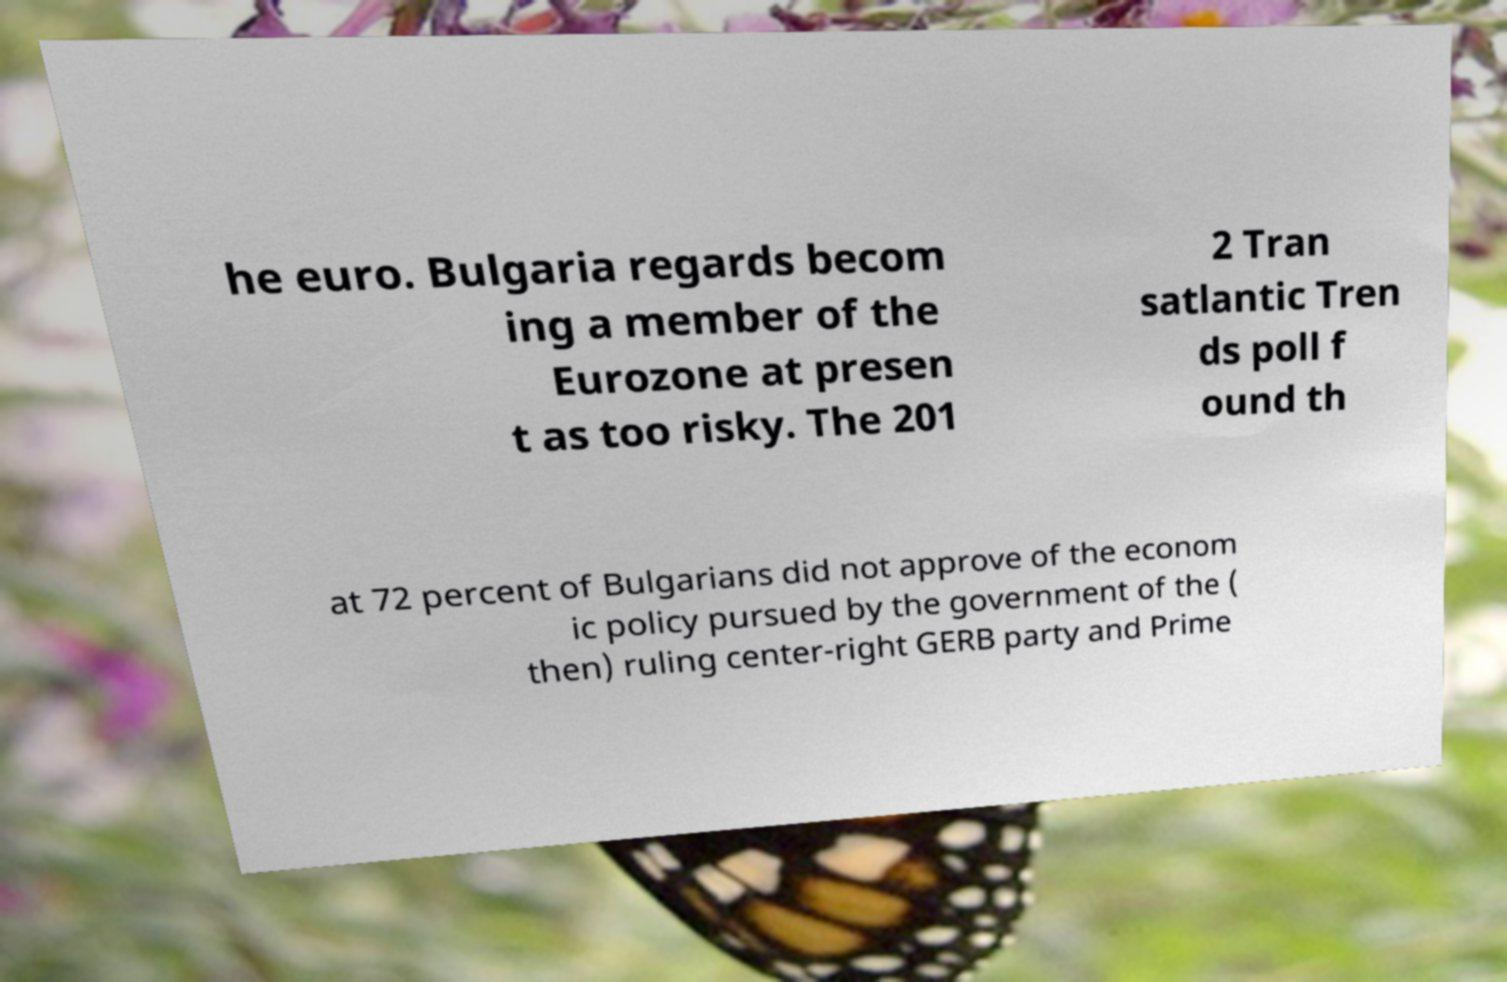Can you accurately transcribe the text from the provided image for me? he euro. Bulgaria regards becom ing a member of the Eurozone at presen t as too risky. The 201 2 Tran satlantic Tren ds poll f ound th at 72 percent of Bulgarians did not approve of the econom ic policy pursued by the government of the ( then) ruling center-right GERB party and Prime 